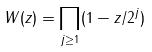Convert formula to latex. <formula><loc_0><loc_0><loc_500><loc_500>W ( z ) = \prod _ { j \geq 1 } ( 1 - z / 2 ^ { j } )</formula> 